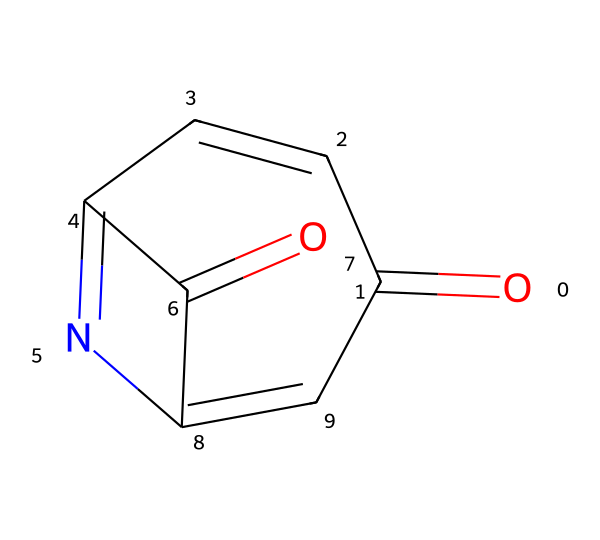What is the molecular formula of this compound? To determine the molecular formula, we count the number of each type of atom represented in the structure. The structure from the provided SMILES shows one carbon atom connected to a nitrogen atom and two oxygen atoms, suggesting a formula of C8H6N2O2. However, there are octagonal rings that also suggest we must account for hydrogens saturating them, leading to C8H6N2O2 as the correct total count of atoms.
Answer: C8H6N2O2 How many nitrogen atoms are present in this chemical? By analyzing the SMILES notation, we identify two nitrogen atoms in the chemical structure. Each nitrogen atom is indicated by the letter 'N', and in this case, they are at distinct positions in the ring.
Answer: two What functional groups can be identified in this compound? Looking at the provided structure, we can identify carbonyl groups (C=O) and an imine (C=N) which indicate the presence of both ketones and amines in the structure. These functional groups are crucial for the chemical's reactivity and properties as a photoresist.
Answer: carbonyl and imine What role does this compound play in circuit printing? This compound, being a diazonaphthoquinone-based photoresist, functions as a photosensitive material used in photolithography processes for microfabrication. Its ability to undergo chemical change upon exposure to light allows it to define patterns on the substrate for circuit layouts.
Answer: photosensitive material How many rings are present in this chemical structure? The structure reveals both a fused and a non-fused ring system. By visual inspection of the carbon backbone and noting the bonds, we find two distinct ring structures that help confer its stability and reactivity as a photoresist.
Answer: two 